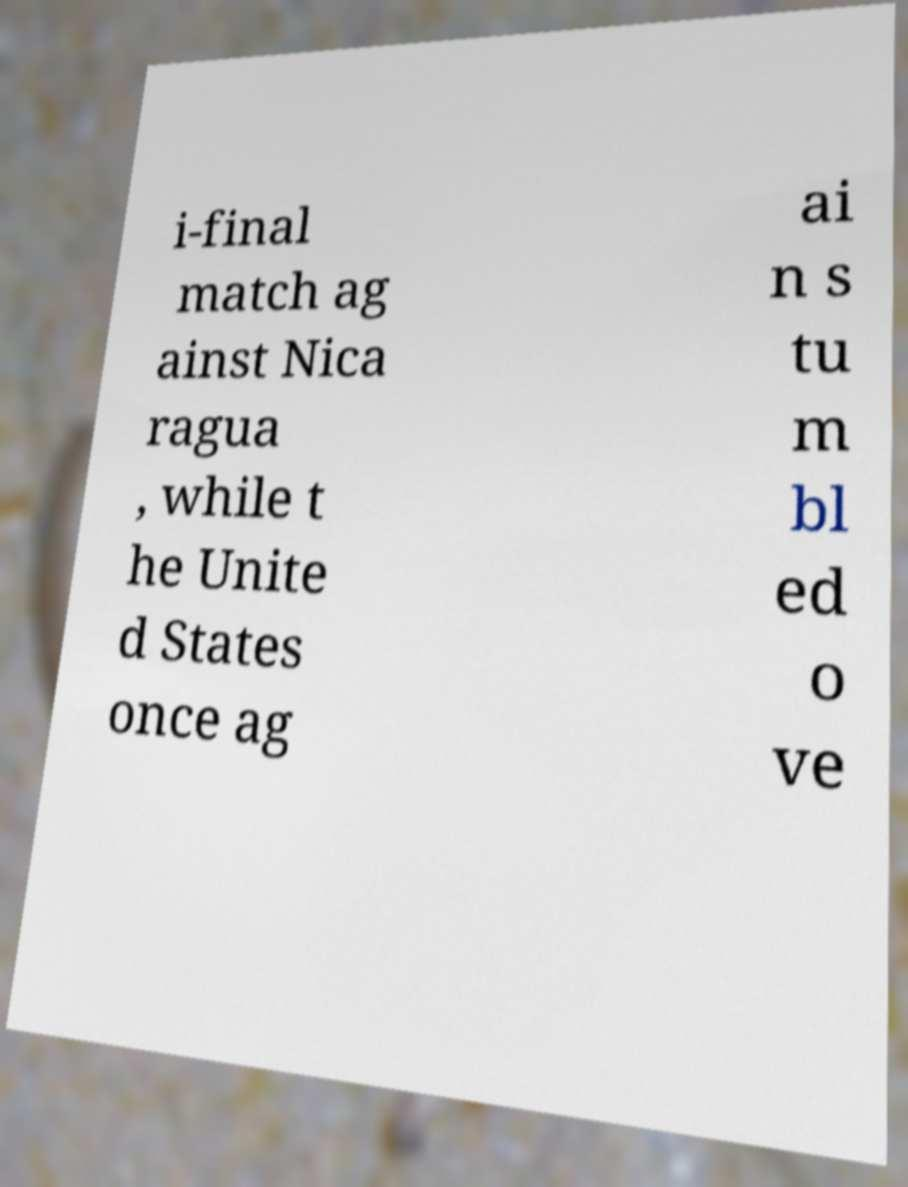Could you assist in decoding the text presented in this image and type it out clearly? i-final match ag ainst Nica ragua , while t he Unite d States once ag ai n s tu m bl ed o ve 